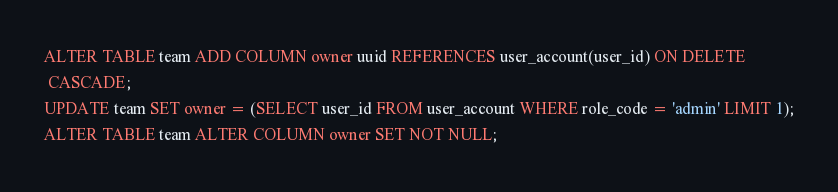<code> <loc_0><loc_0><loc_500><loc_500><_SQL_>ALTER TABLE team ADD COLUMN owner uuid REFERENCES user_account(user_id) ON DELETE
 CASCADE;
UPDATE team SET owner = (SELECT user_id FROM user_account WHERE role_code = 'admin' LIMIT 1);
ALTER TABLE team ALTER COLUMN owner SET NOT NULL;
</code> 